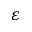Convert formula to latex. <formula><loc_0><loc_0><loc_500><loc_500>\varepsilon</formula> 